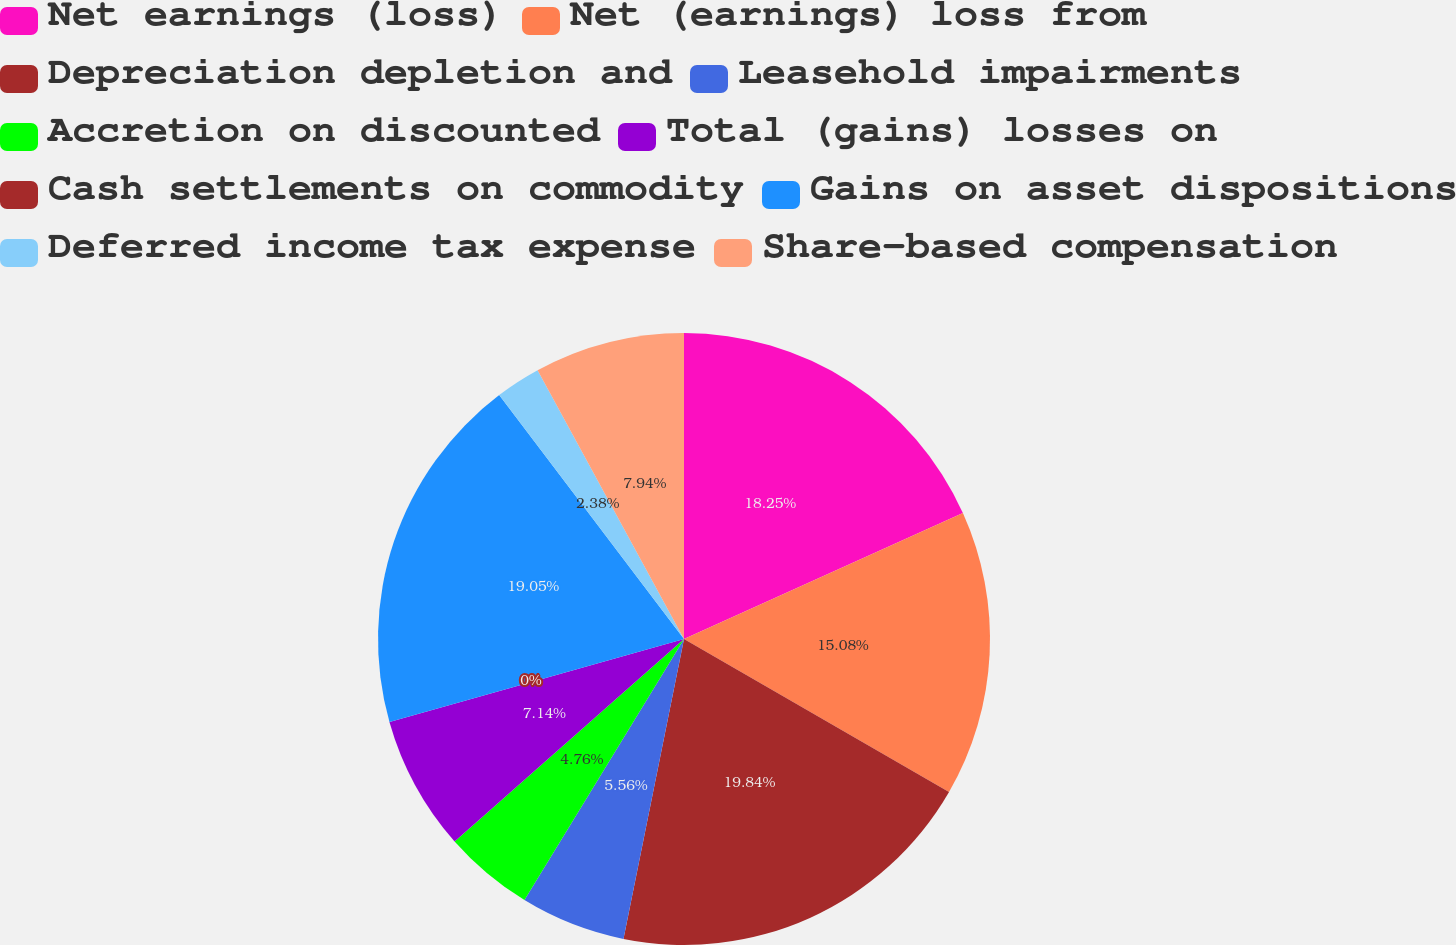<chart> <loc_0><loc_0><loc_500><loc_500><pie_chart><fcel>Net earnings (loss)<fcel>Net (earnings) loss from<fcel>Depreciation depletion and<fcel>Leasehold impairments<fcel>Accretion on discounted<fcel>Total (gains) losses on<fcel>Cash settlements on commodity<fcel>Gains on asset dispositions<fcel>Deferred income tax expense<fcel>Share-based compensation<nl><fcel>18.25%<fcel>15.08%<fcel>19.84%<fcel>5.56%<fcel>4.76%<fcel>7.14%<fcel>0.0%<fcel>19.05%<fcel>2.38%<fcel>7.94%<nl></chart> 